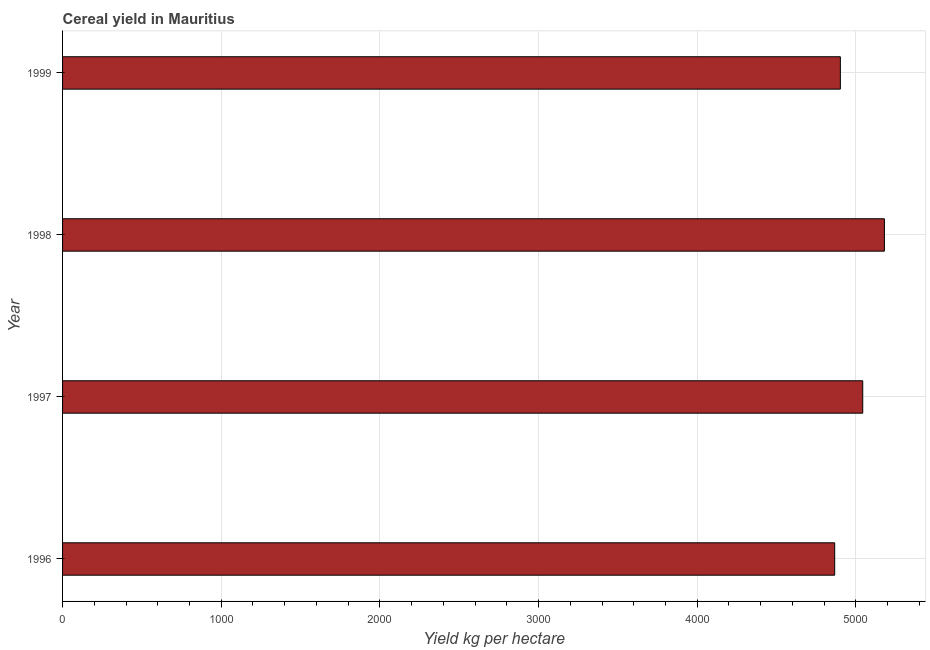Does the graph contain grids?
Offer a very short reply. Yes. What is the title of the graph?
Provide a succinct answer. Cereal yield in Mauritius. What is the label or title of the X-axis?
Provide a succinct answer. Yield kg per hectare. What is the cereal yield in 1997?
Provide a succinct answer. 5043.48. Across all years, what is the maximum cereal yield?
Make the answer very short. 5180. Across all years, what is the minimum cereal yield?
Ensure brevity in your answer.  4866.67. In which year was the cereal yield minimum?
Offer a terse response. 1996. What is the sum of the cereal yield?
Give a very brief answer. 2.00e+04. What is the difference between the cereal yield in 1997 and 1998?
Give a very brief answer. -136.52. What is the average cereal yield per year?
Provide a short and direct response. 4998.15. What is the median cereal yield?
Give a very brief answer. 4972.96. What is the ratio of the cereal yield in 1996 to that in 1998?
Offer a terse response. 0.94. What is the difference between the highest and the second highest cereal yield?
Your response must be concise. 136.52. What is the difference between the highest and the lowest cereal yield?
Keep it short and to the point. 313.33. Are all the bars in the graph horizontal?
Your response must be concise. Yes. What is the difference between two consecutive major ticks on the X-axis?
Make the answer very short. 1000. What is the Yield kg per hectare of 1996?
Your answer should be compact. 4866.67. What is the Yield kg per hectare of 1997?
Give a very brief answer. 5043.48. What is the Yield kg per hectare of 1998?
Your answer should be very brief. 5180. What is the Yield kg per hectare of 1999?
Provide a short and direct response. 4902.44. What is the difference between the Yield kg per hectare in 1996 and 1997?
Offer a terse response. -176.81. What is the difference between the Yield kg per hectare in 1996 and 1998?
Ensure brevity in your answer.  -313.33. What is the difference between the Yield kg per hectare in 1996 and 1999?
Keep it short and to the point. -35.77. What is the difference between the Yield kg per hectare in 1997 and 1998?
Offer a terse response. -136.52. What is the difference between the Yield kg per hectare in 1997 and 1999?
Provide a short and direct response. 141.04. What is the difference between the Yield kg per hectare in 1998 and 1999?
Give a very brief answer. 277.56. What is the ratio of the Yield kg per hectare in 1996 to that in 1997?
Provide a succinct answer. 0.96. What is the ratio of the Yield kg per hectare in 1996 to that in 1998?
Offer a terse response. 0.94. What is the ratio of the Yield kg per hectare in 1997 to that in 1998?
Your answer should be very brief. 0.97. What is the ratio of the Yield kg per hectare in 1997 to that in 1999?
Offer a very short reply. 1.03. What is the ratio of the Yield kg per hectare in 1998 to that in 1999?
Ensure brevity in your answer.  1.06. 